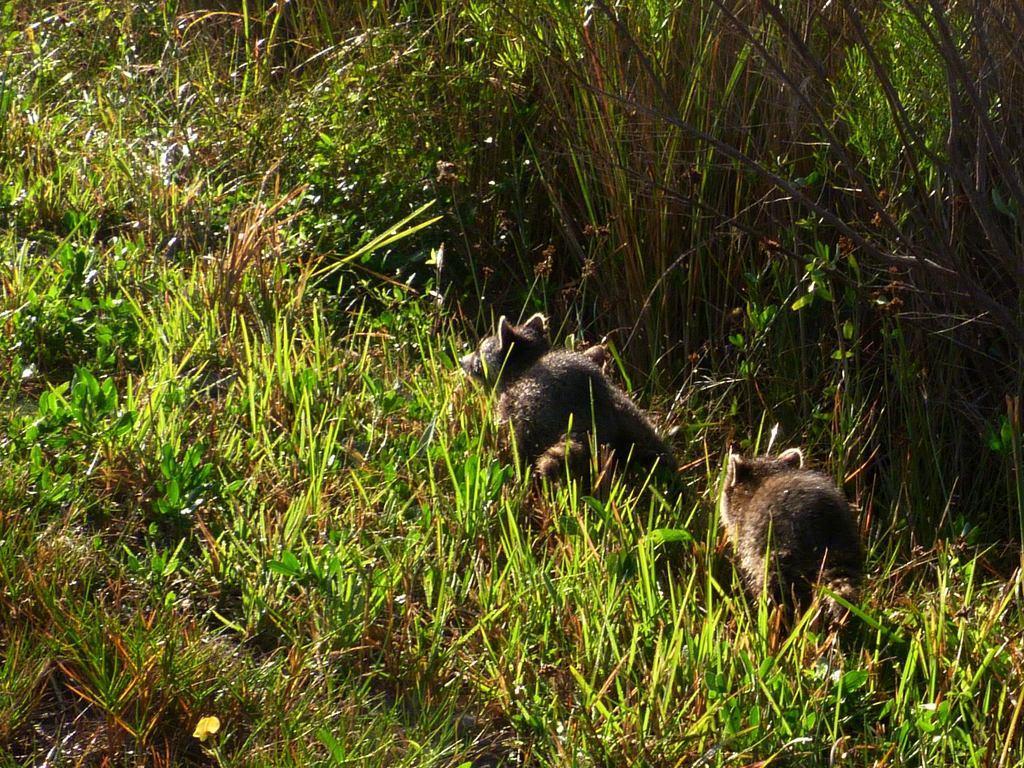Can you describe this image briefly? In the picture I can see the animals and green grass. 